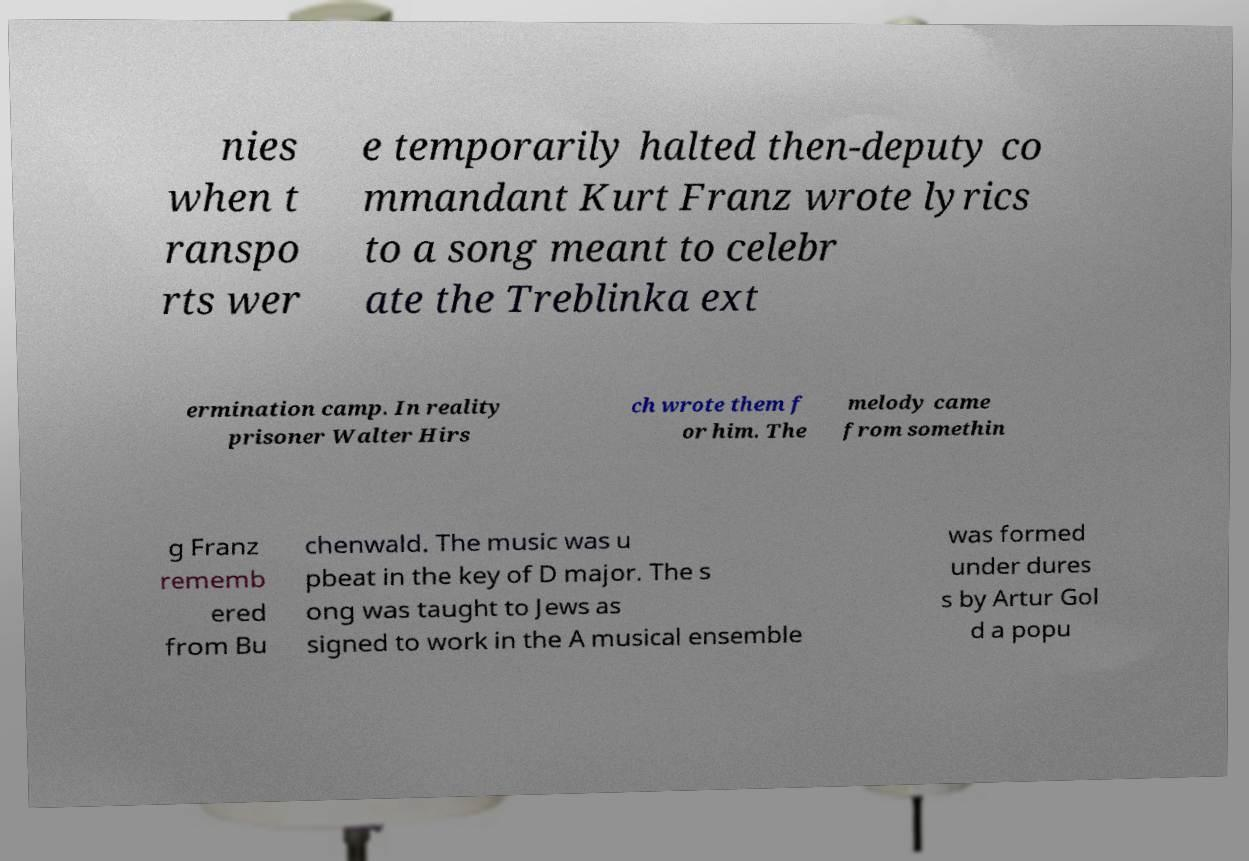Please read and relay the text visible in this image. What does it say? nies when t ranspo rts wer e temporarily halted then-deputy co mmandant Kurt Franz wrote lyrics to a song meant to celebr ate the Treblinka ext ermination camp. In reality prisoner Walter Hirs ch wrote them f or him. The melody came from somethin g Franz rememb ered from Bu chenwald. The music was u pbeat in the key of D major. The s ong was taught to Jews as signed to work in the A musical ensemble was formed under dures s by Artur Gol d a popu 